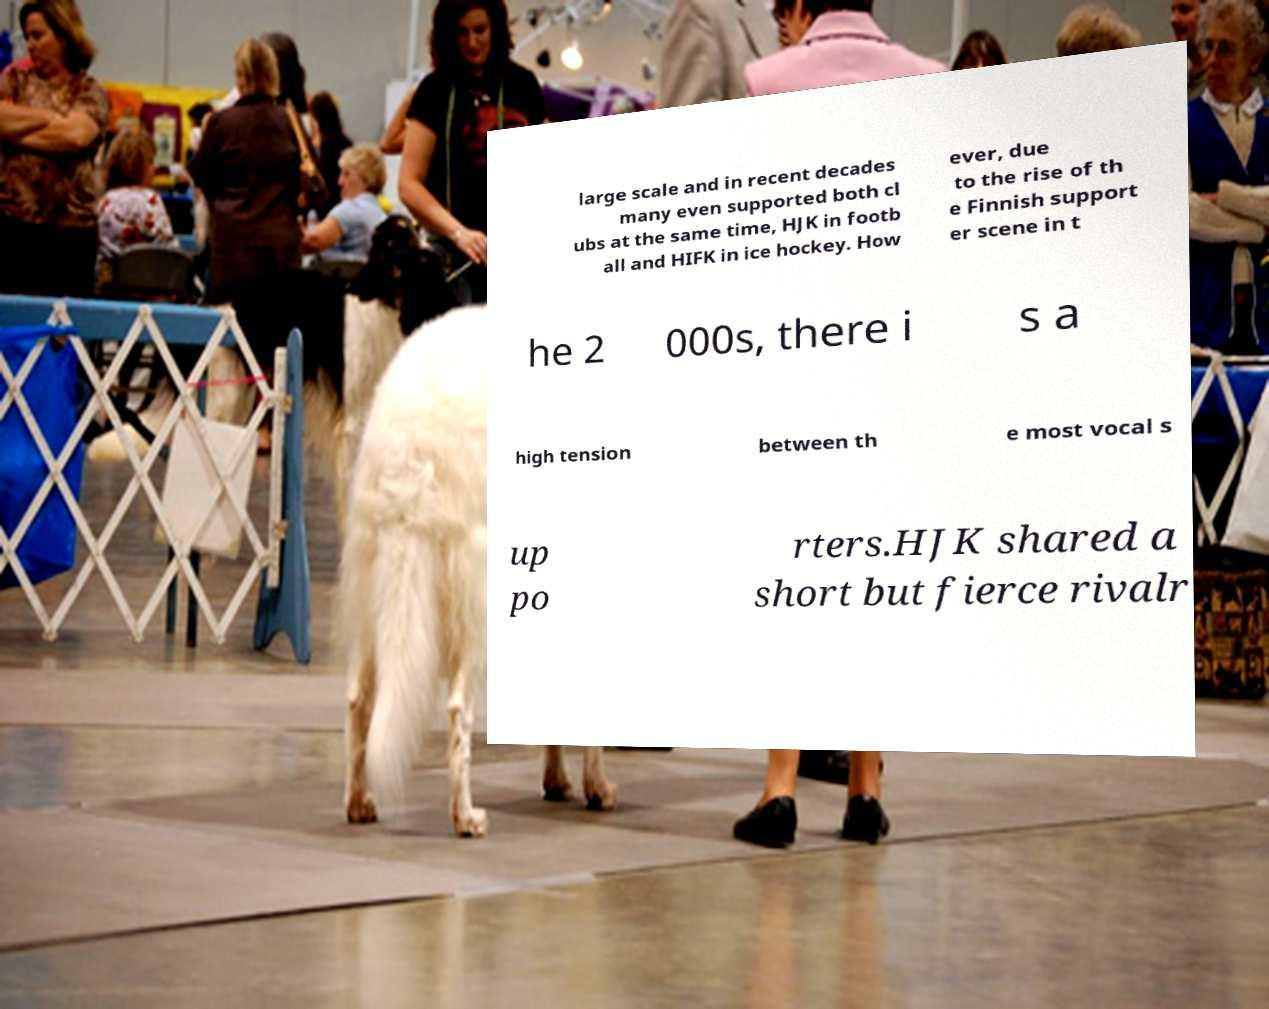There's text embedded in this image that I need extracted. Can you transcribe it verbatim? large scale and in recent decades many even supported both cl ubs at the same time, HJK in footb all and HIFK in ice hockey. How ever, due to the rise of th e Finnish support er scene in t he 2 000s, there i s a high tension between th e most vocal s up po rters.HJK shared a short but fierce rivalr 